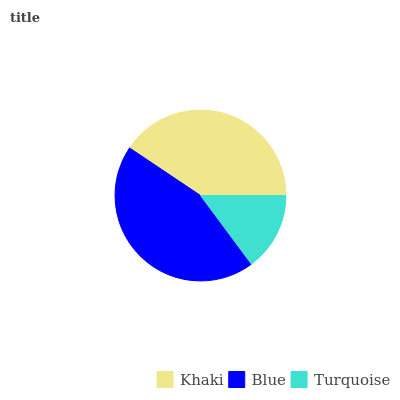Is Turquoise the minimum?
Answer yes or no. Yes. Is Blue the maximum?
Answer yes or no. Yes. Is Blue the minimum?
Answer yes or no. No. Is Turquoise the maximum?
Answer yes or no. No. Is Blue greater than Turquoise?
Answer yes or no. Yes. Is Turquoise less than Blue?
Answer yes or no. Yes. Is Turquoise greater than Blue?
Answer yes or no. No. Is Blue less than Turquoise?
Answer yes or no. No. Is Khaki the high median?
Answer yes or no. Yes. Is Khaki the low median?
Answer yes or no. Yes. Is Turquoise the high median?
Answer yes or no. No. Is Turquoise the low median?
Answer yes or no. No. 